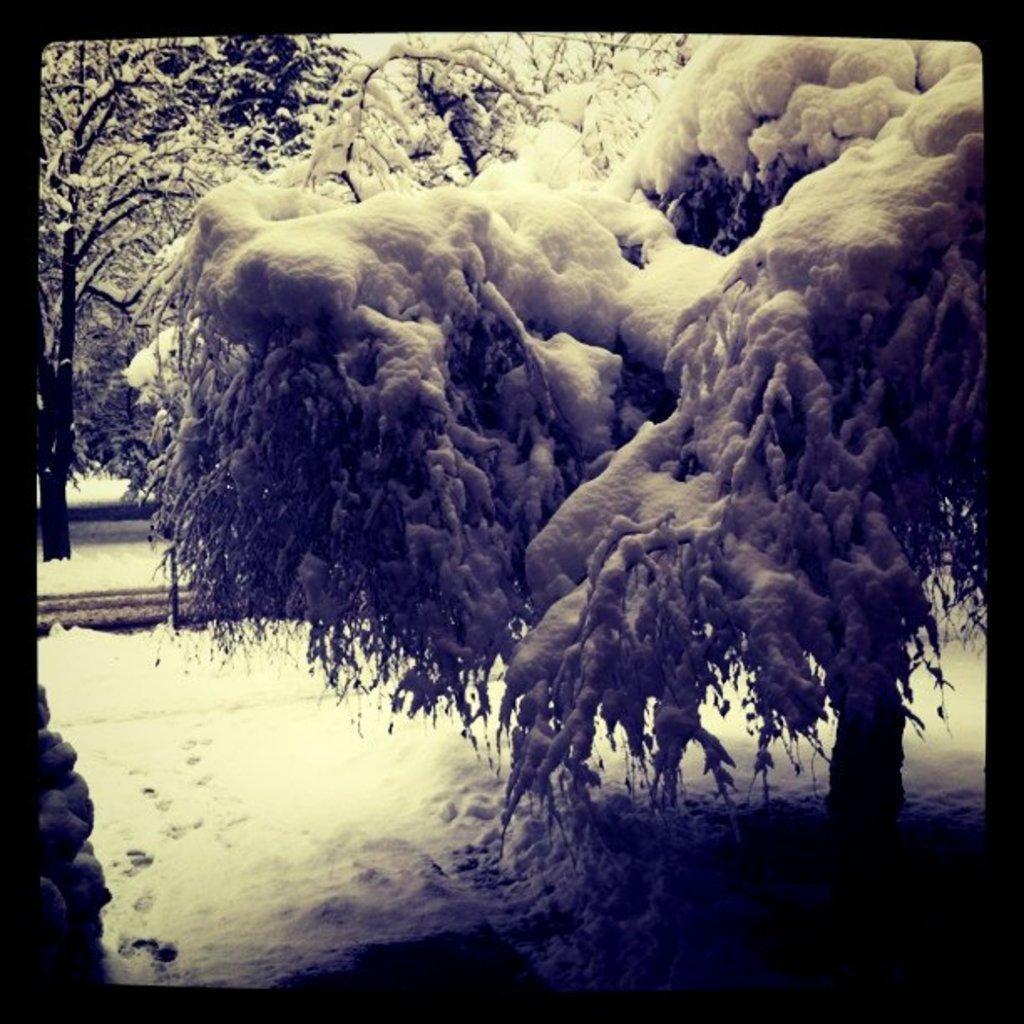How would you summarize this image in a sentence or two? In this image we can see some trees on which there is snow. 